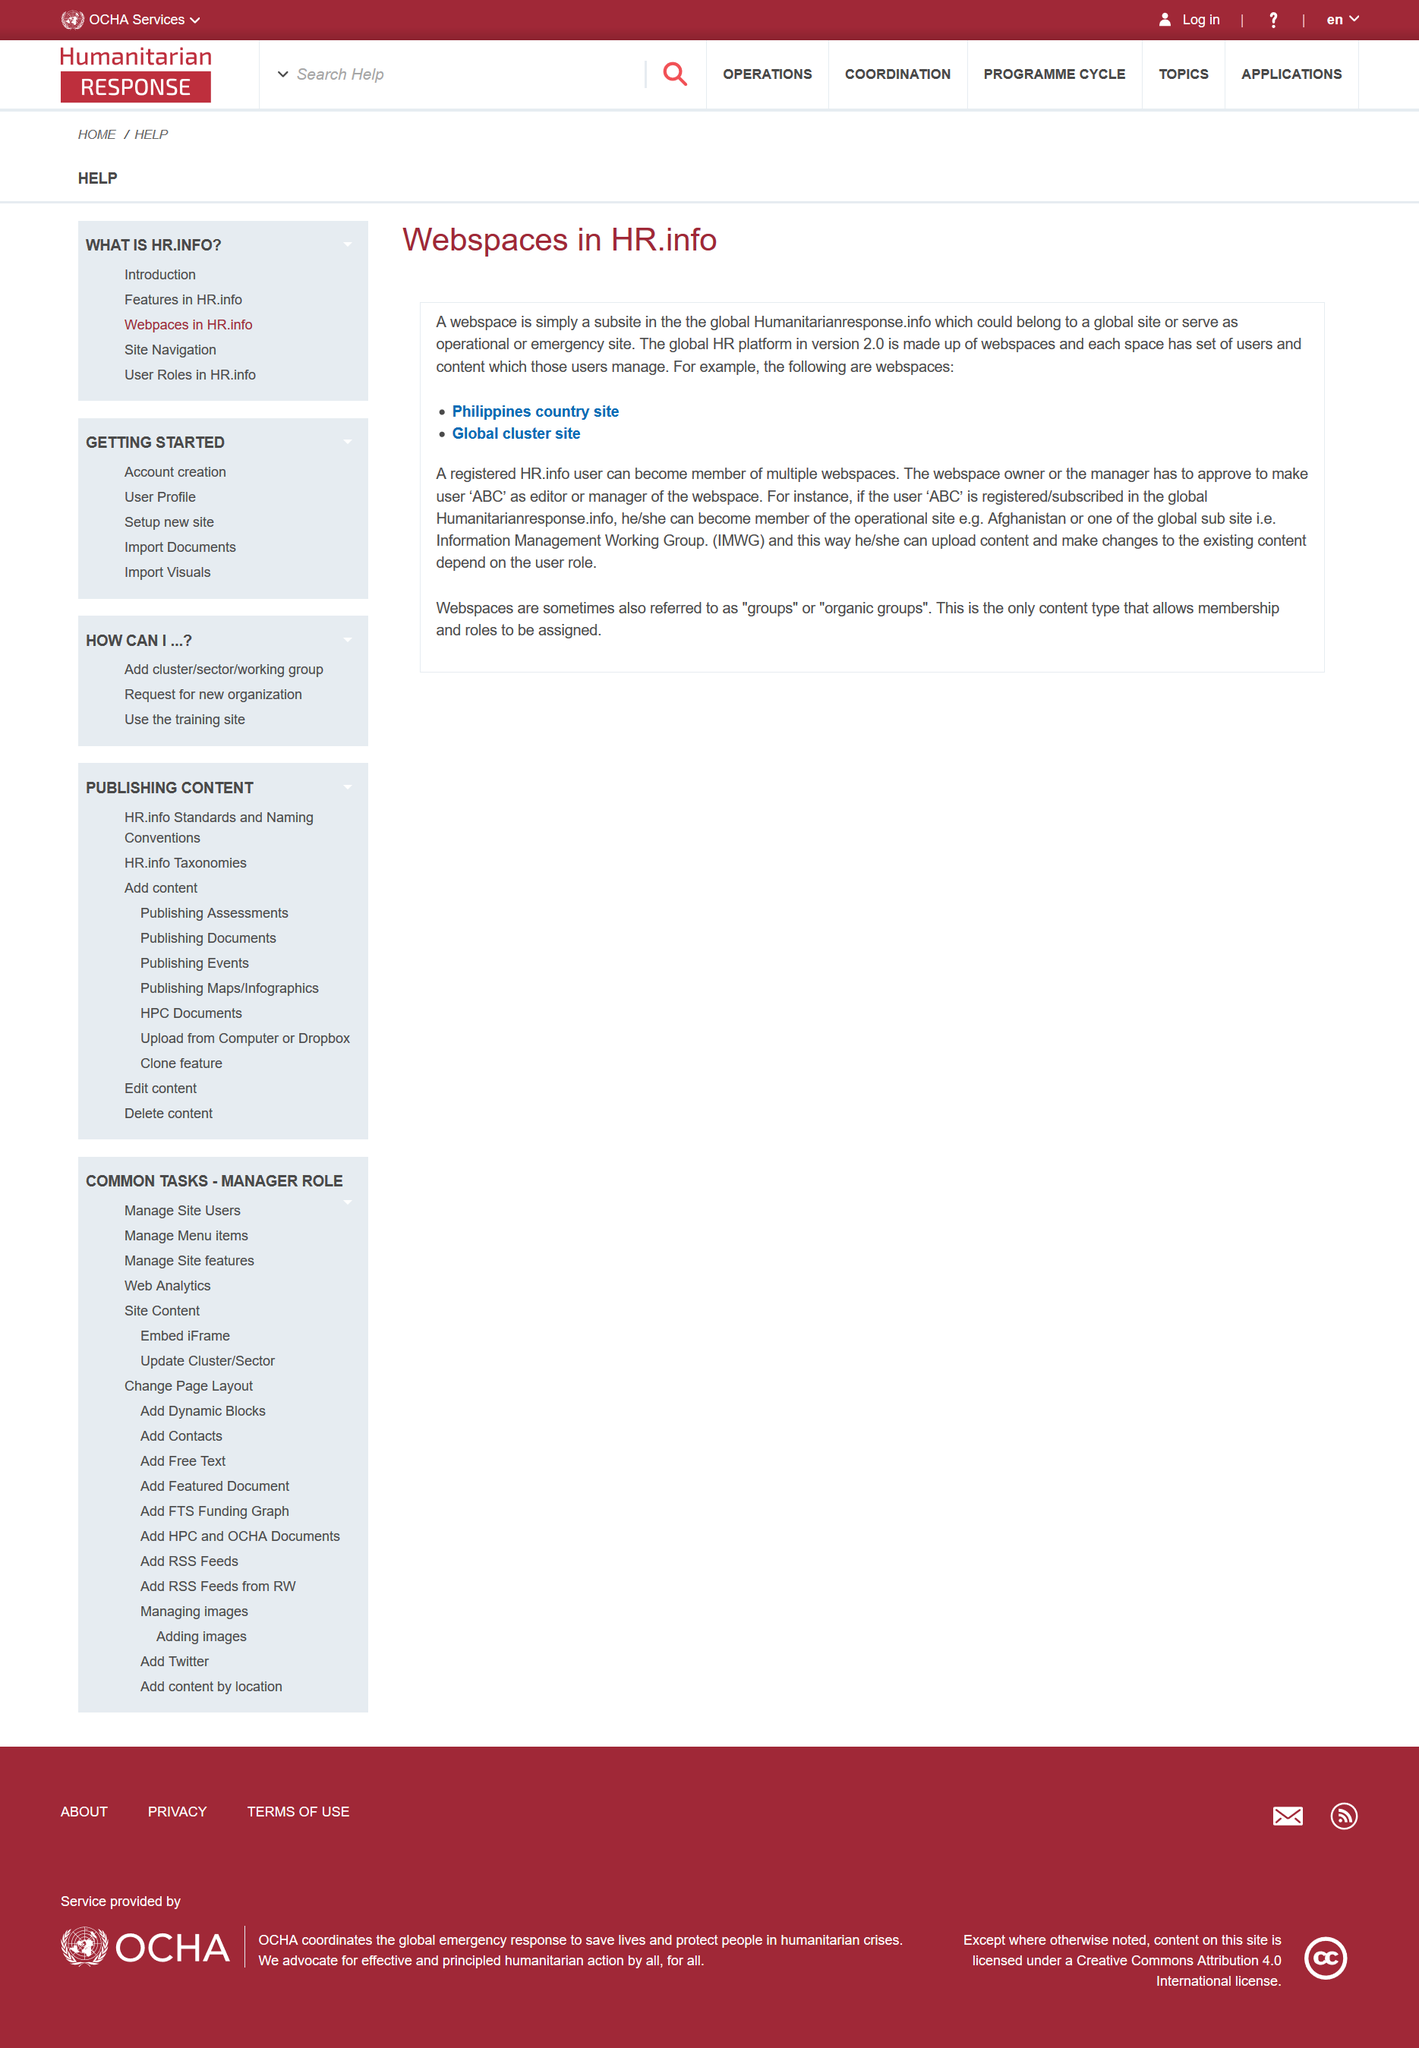Specify some key components in this picture. The information provides a comprehensive overview of webspaces. A webspace is a subsite that is part of a larger website. Memberships and roles can only be assigned to webspaces, and not to other content types. 